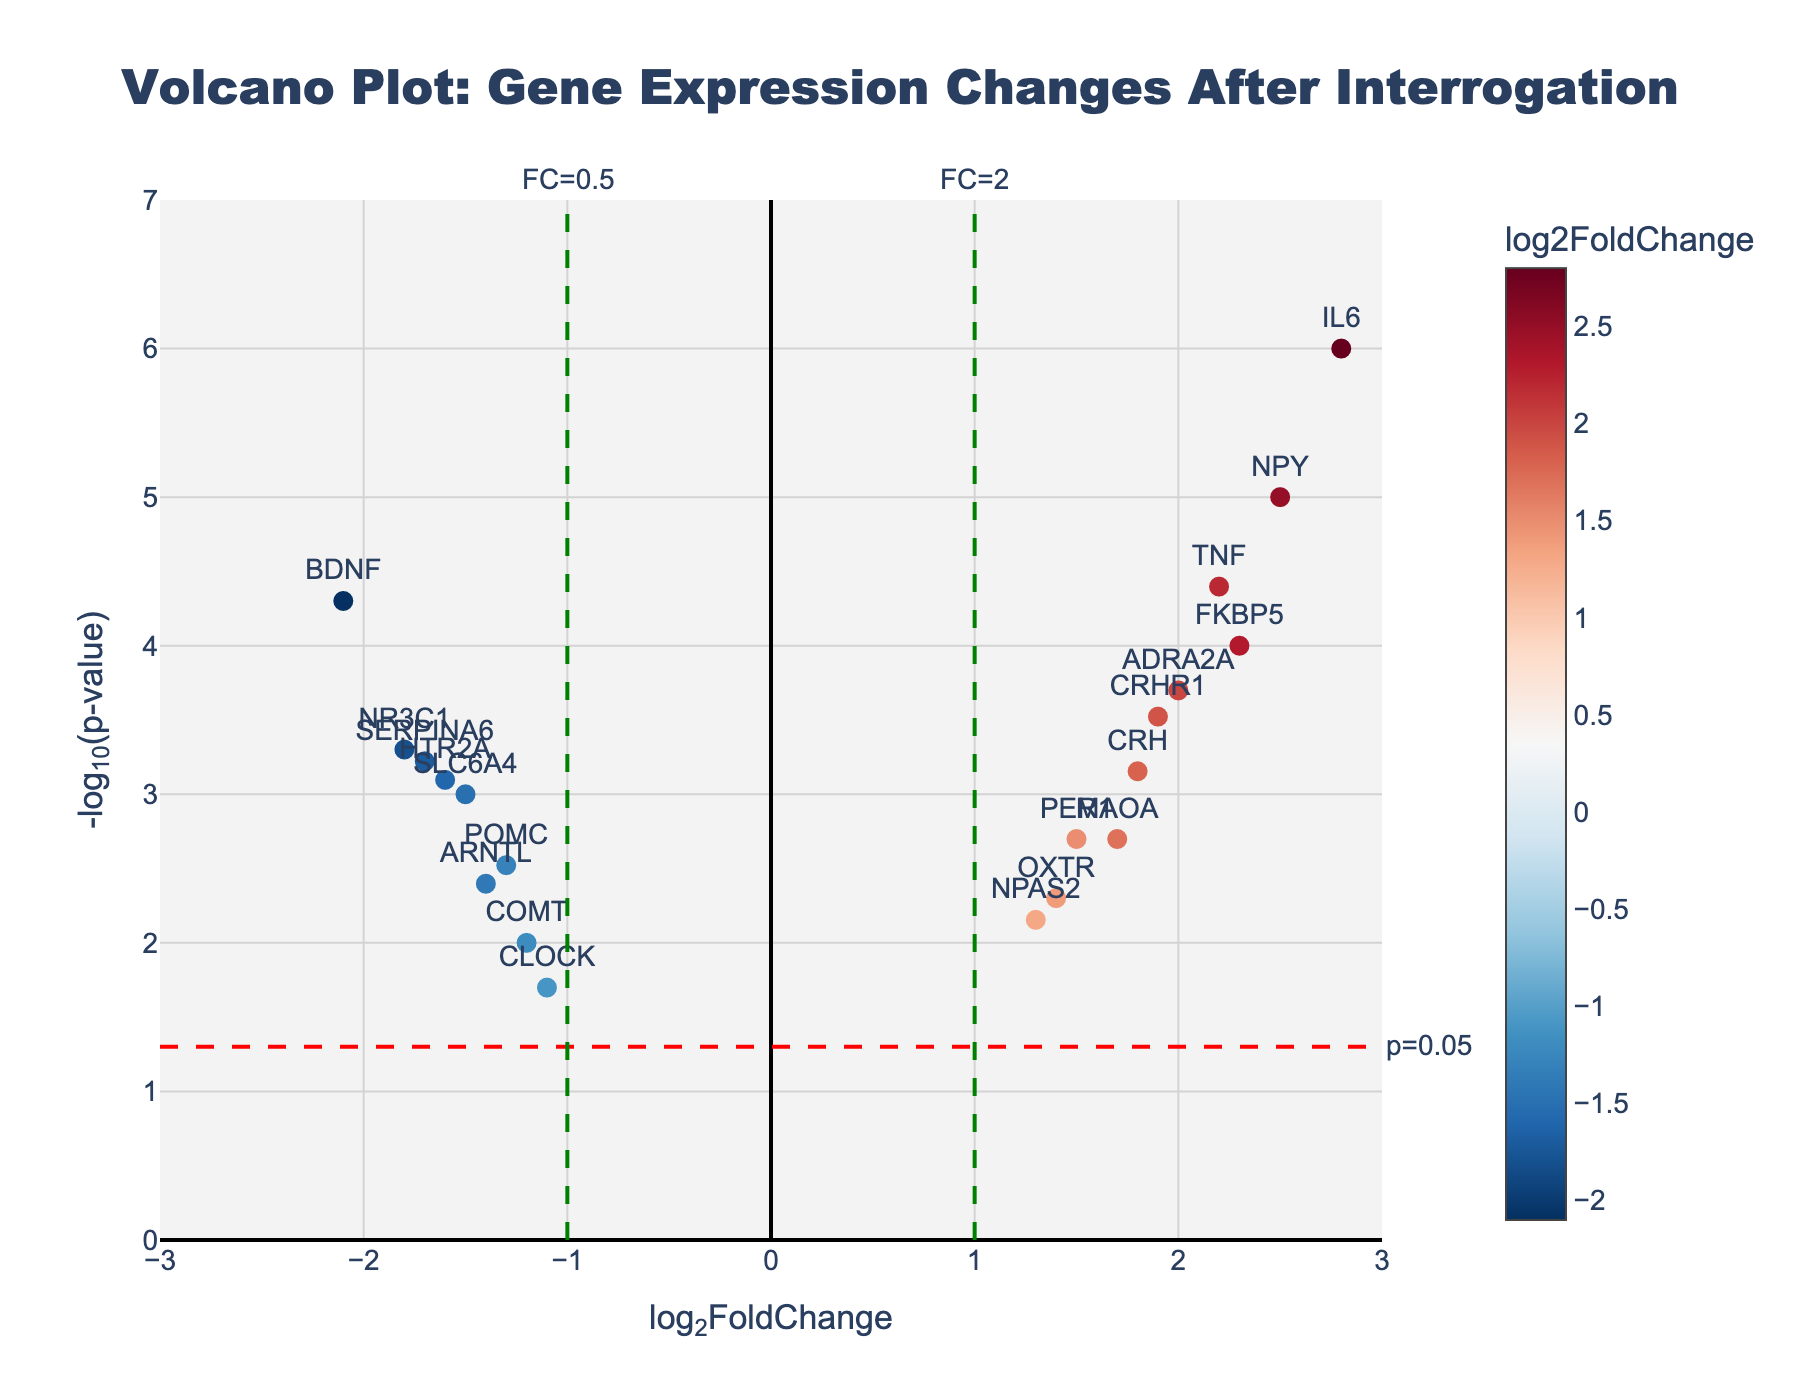How many data points are shown in the figure? To count the data points, look at each marker representing a gene on the plot. The total number of markers corresponds to the number of data points.
Answer: 20 What is the title of the figure? The title is located at the top center of the plot and provides a summary of what the figure represents.
Answer: Volcano Plot: Gene Expression Changes After Interrogation Which gene has the highest log2FoldChange value? Look at the data points along the x-axis and find the one farthest to the right. The hovering or text annotation shows the gene name.
Answer: IL6 What is the common characteristic of SLC6A4 and BDNF in this plot? Observe the x-axis values for both genes. Both genes are on the left side, indicating negative log2FoldChange values.
Answer: They both have negative log2FoldChange values Which genes have a p-value lower than or equal to 0.0001? To determine this, find genes above the horizontal dashed line labeled "p=0.05" (the higher -log10(p-value), the lower the p-value). Look at the data points with y-values above this threshold.
Answer: FKBP5, NPY, IL6, TNF, CRHR1, NR3C1, ADRA2A, OXTR, SERPINA6 Which gene is closest to the significance threshold on the y-axis? Identify the horizontal significance line at y = 1.3 (-log10(0.05)) and find the gene closest to this line. EXAMPLE: CLOCK or COMT has the closest value.
Answer: CLOCK What is the log2FoldChange range of the genes shown in the plot? To find the range, examine the extreme left and right points on the x-axis. Identify the lowest and highest log2FoldChange values.
Answer: -2.1 to 2.8 Which gene has a log2FoldChange just below 2.0? Look for a data point slightly to the left of the vertical line at x = 2.0 and identify the corresponding gene.
Answer: ADRA2A Compare the expression changes between NPY and BDNF. Which shows a higher fold change and which shows a lower p-value? NPY has a log2FoldChange of 2.5 and a very low p-value (high -log10(p-value)), while BDNF has a log2FoldChange of -2.1 and a low p-value but not as low as NPY's.
Answer: NPY has a higher fold change and lower p-value What does the red dashed line on the plot represent? The red dashed line is at y = 1.3, representing the significance threshold of p = 0.05. This line helps us identify genes with p-values ≤ 0.05.
Answer: p=0.05 significance threshold 